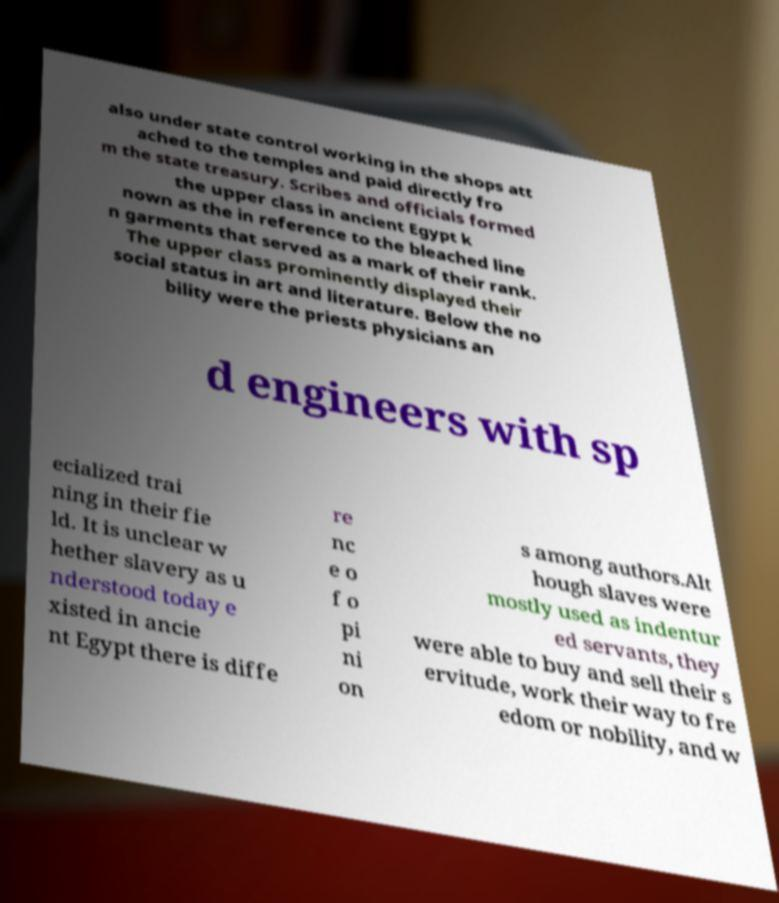Could you extract and type out the text from this image? also under state control working in the shops att ached to the temples and paid directly fro m the state treasury. Scribes and officials formed the upper class in ancient Egypt k nown as the in reference to the bleached line n garments that served as a mark of their rank. The upper class prominently displayed their social status in art and literature. Below the no bility were the priests physicians an d engineers with sp ecialized trai ning in their fie ld. It is unclear w hether slavery as u nderstood today e xisted in ancie nt Egypt there is diffe re nc e o f o pi ni on s among authors.Alt hough slaves were mostly used as indentur ed servants, they were able to buy and sell their s ervitude, work their way to fre edom or nobility, and w 